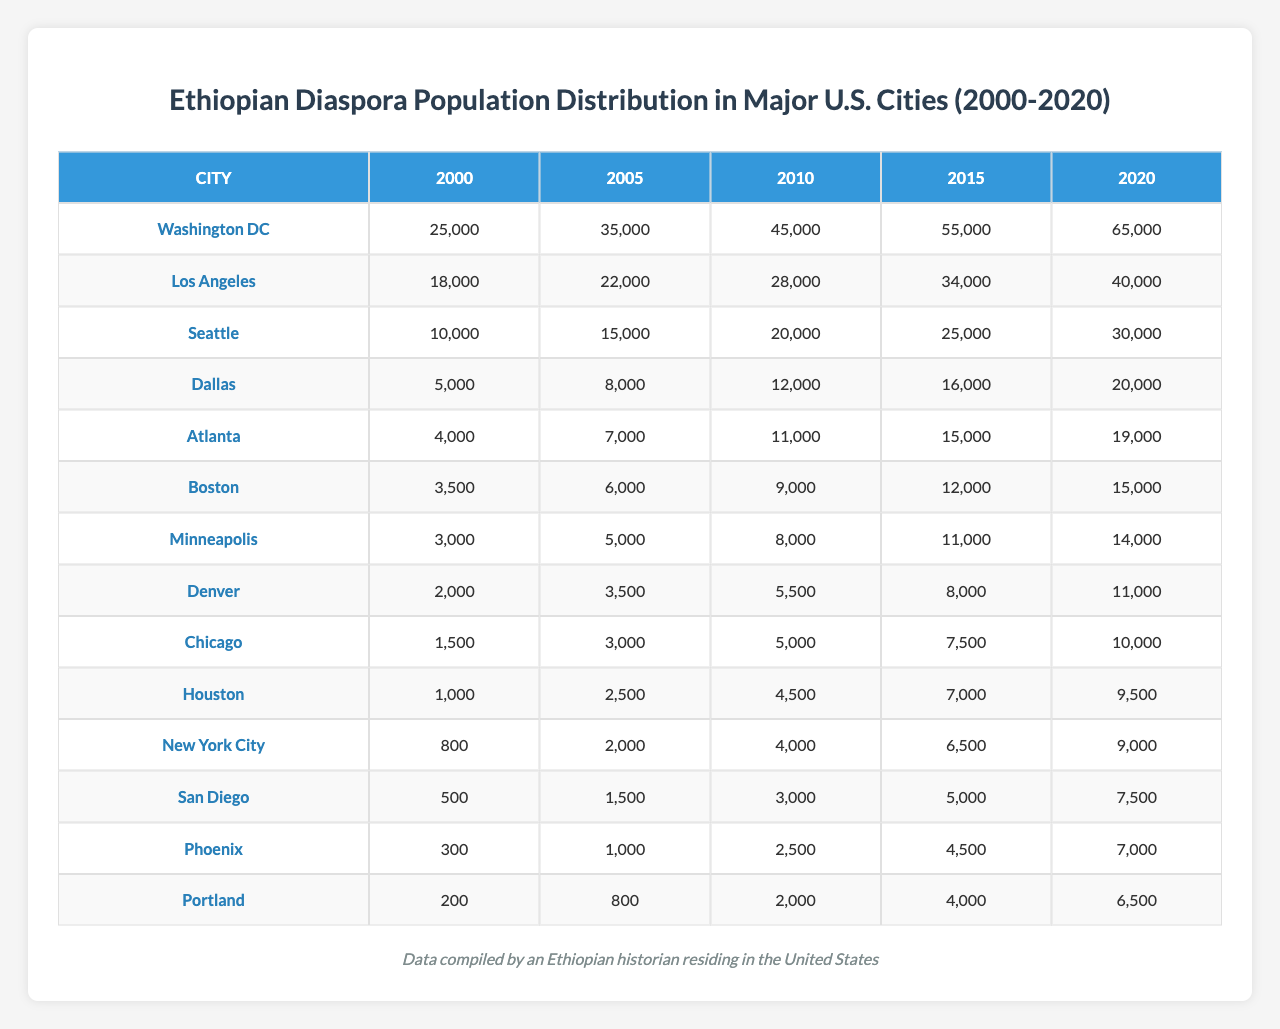What was the Ethiopian diaspora population in Washington DC in 2010? According to the table, the population in Washington DC in 2010 is listed as 45,000.
Answer: 45,000 Which city had the largest Ethiopian diaspora population in 2020? By checking the 2020 column in the table, Washington DC has the highest population with 65,000, compared to other cities.
Answer: Washington DC What was the increase in the Ethiopian diaspora population in Dallas from 2000 to 2020? In 2000, the population in Dallas was 5,000 and in 2020 it was 20,000. The increase is calculated as 20,000 - 5,000 = 15,000.
Answer: 15,000 How many more Ethiopians were in Atlanta than in Chicago in 2015? The population in Atlanta in 2015 was 15,000 while in Chicago it was 7,500. The difference is 15,000 - 7,500 = 7,500.
Answer: 7,500 What was the total Ethiopian diaspora population in the five cities with the highest populations in 2020? The five cities with the highest populations in 2020 are Washington DC (65,000), Los Angeles (40,000), Seattle (30,000), Dallas (20,000), and Atlanta (19,000). Summing these gives 65,000 + 40,000 + 30,000 + 20,000 + 19,000 = 174,000.
Answer: 174,000 Did the Ethiopian diaspora population in New York City meet or exceed 5,000 in any year between 2000 and 2020? The population in New York City reached 6,500 in 2015 and 9,000 in 2020, which both exceed 5,000.
Answer: Yes What was the average Ethiopian diaspora population in Seattle from 2000 to 2020? The populations for Seattle are 10,000, 15,000, 20,000, 25,000, and 30,000 over the five years. Summing these gives 100,000, and dividing by 5 yields an average of 20,000.
Answer: 20,000 Which city experienced the smallest Ethiopian population growth from 2000 to 2020? The smallest growth can be seen in Minneapolis, which grew from 3,000 to 14,000, a difference of 11,000. Checking other cities shows they all had larger growths.
Answer: Minneapolis How does the population of Ethiopians in San Diego in 2020 compare to that in Houston in the same year? In 2020, San Diego had a population of 7,500 while Houston had 9,500. Hence, Houston had a larger population.
Answer: Houston had more In what year did the Ethiopian diaspora population in Boston first exceed 10,000? By examining the table, Boston surpassed 10,000 in 2015 when the population was recorded at 12,000.
Answer: 2015 